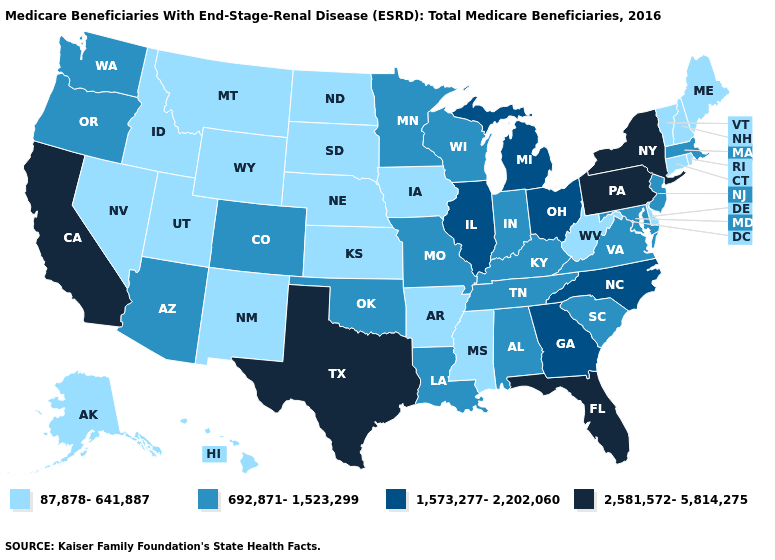What is the highest value in the USA?
Give a very brief answer. 2,581,572-5,814,275. What is the lowest value in states that border Kansas?
Be succinct. 87,878-641,887. What is the lowest value in the Northeast?
Short answer required. 87,878-641,887. Is the legend a continuous bar?
Concise answer only. No. What is the value of Colorado?
Answer briefly. 692,871-1,523,299. Does Kentucky have a higher value than Alabama?
Give a very brief answer. No. Among the states that border Pennsylvania , which have the lowest value?
Concise answer only. Delaware, West Virginia. Does Virginia have a lower value than Louisiana?
Short answer required. No. What is the highest value in the USA?
Be succinct. 2,581,572-5,814,275. Which states have the lowest value in the USA?
Answer briefly. Alaska, Arkansas, Connecticut, Delaware, Hawaii, Idaho, Iowa, Kansas, Maine, Mississippi, Montana, Nebraska, Nevada, New Hampshire, New Mexico, North Dakota, Rhode Island, South Dakota, Utah, Vermont, West Virginia, Wyoming. Does New York have the highest value in the Northeast?
Write a very short answer. Yes. Name the states that have a value in the range 1,573,277-2,202,060?
Answer briefly. Georgia, Illinois, Michigan, North Carolina, Ohio. Which states hav the highest value in the West?
Quick response, please. California. Among the states that border New Jersey , does Pennsylvania have the lowest value?
Short answer required. No. Which states hav the highest value in the West?
Quick response, please. California. 